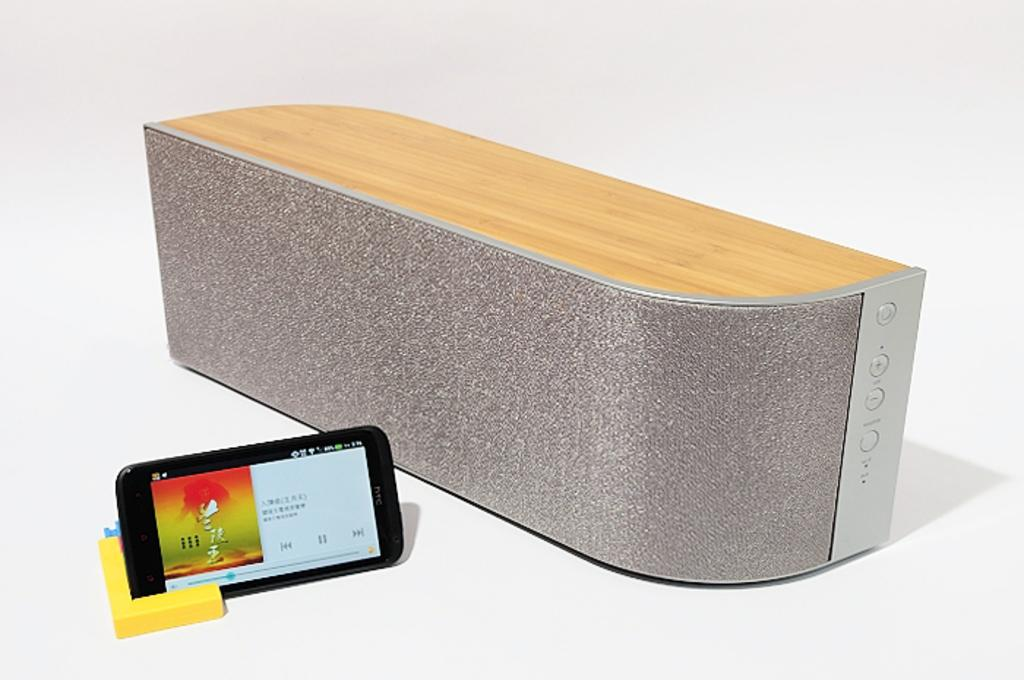What device is present in the image that can produce sound? There is a speaker in the image. What object is designed to hold a mobile phone in the image? There is a phone holder in the image. What electronic device is visible in the image? There is a mobile phone in the image. What is the mobile phone's screen displaying? The mobile phone's screen displays a music player. What type of scarf is wrapped around the speaker in the image? There is no scarf present in the image; the speaker is not wrapped in any fabric. What is the condition of the phone holder in the image? The condition of the phone holder cannot be determined from the image alone, as it only shows the object's presence and not its state. 